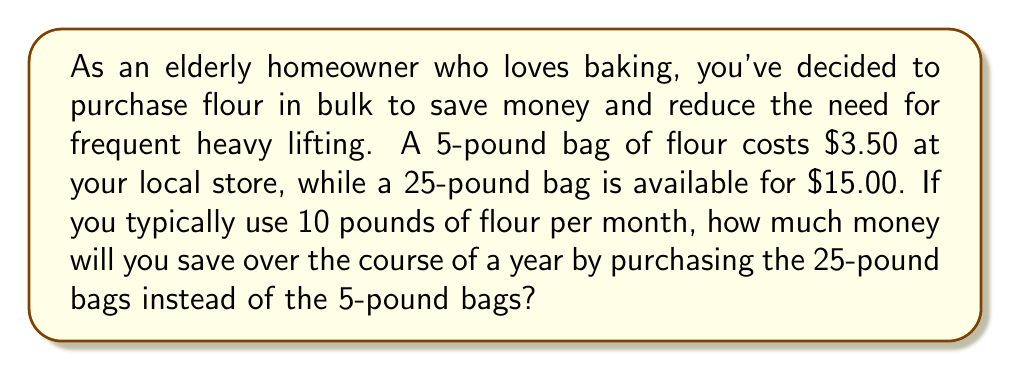Show me your answer to this math problem. Let's break this problem down step-by-step:

1. Calculate the cost per pound for each option:
   - 5-pound bag: $\frac{$3.50}{5\text{ lbs}} = $0.70$ per pound
   - 25-pound bag: $\frac{$15.00}{25\text{ lbs}} = $0.60$ per pound

2. Calculate how many pounds of flour are used in a year:
   $10\text{ lbs/month} \times 12\text{ months} = 120\text{ lbs/year}$

3. Calculate the cost for a year using 5-pound bags:
   $120\text{ lbs} \times $0.70$/\text{lb} = $84.00$

4. Calculate the cost for a year using 25-pound bags:
   $120\text{ lbs} \times $0.60$/\text{lb} = $72.00$

5. Calculate the savings by subtracting the cost of 25-pound bags from the cost of 5-pound bags:
   $84.00 - $72.00 = $12.00$

Therefore, by purchasing flour in 25-pound bags instead of 5-pound bags, you will save $12.00 over the course of a year.
Answer: $12.00 